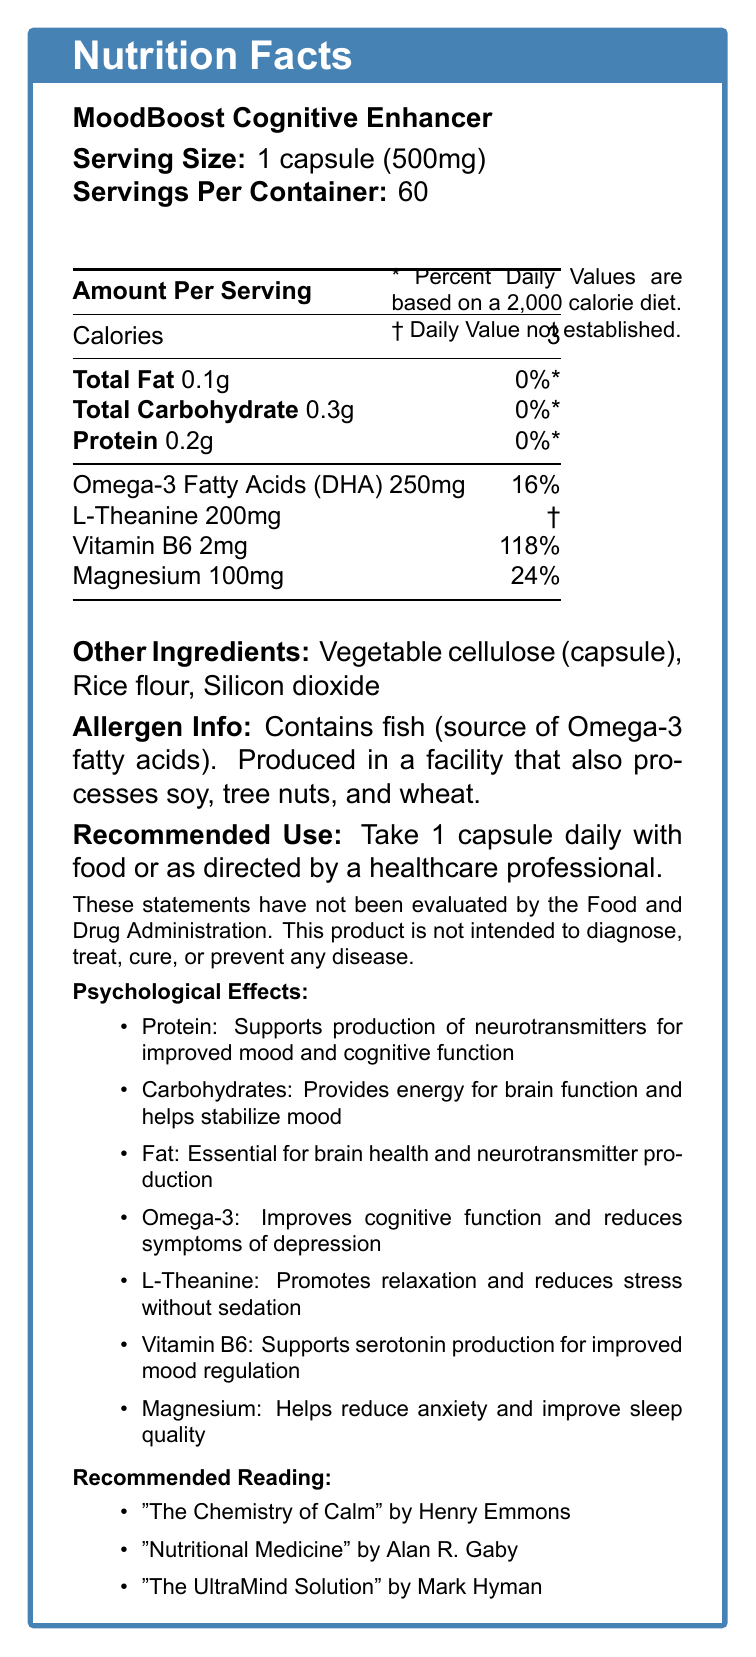what is the serving size for MoodBoost Cognitive Enhancer? The serving size is clearly mentioned in the document as "1 capsule (500mg)".
Answer: 1 capsule (500mg) how much protein does one capsule contain? The document specifies that one capsule contains 0.2g of protein.
Answer: 0.2g what percentage of the daily value for Vitamin B6 does one capsule provide? According to the document, one capsule provides 118% of the daily value for Vitamin B6.
Answer: 118% how does L-Theanine psychologically affect mood and cognition? The psychological effects of L-Theanine are noted in the document as promoting relaxation and reducing stress without sedation.
Answer: Promotes relaxation and reduces stress without sedation what is the main dietary source of Omega-3 fatty acids in this supplement? The document states that the supplement contains fish as the source of Omega-3 fatty acids.
Answer: Fish which macronutrient in this supplement is essential for brain health and neurotransmitter production? A. Carbohydrates B. Protein C. Fat D. L-Theanine The document mentions that fat is essential for brain health and neurotransmitter production.
Answer: C. Fat what is the serving size of Omega-3 Fatty Acids (DHA) per capsule? A. 2mg B. 100mg C. 200mg D. 250mg The serving size of Omega-3 Fatty Acids (DHA) per capsule is listed as 250mg in the document.
Answer: D. 250mg does this product contain any allergens? The document mentions that the product contains fish and is produced in a facility that processes soy, tree nuts, and wheat.
Answer: Yes summarize the main idea of the document. The document provides comprehensive nutritional information about the supplement, including macronutrients, micronutrients, their psychological effects, ingredients, allergy information, usage recommendations, and references to related books.
Answer: The document provides the Nutrition Facts for "MoodBoost Cognitive Enhancer", detailing serving size, macronutrient and micronutrient content, psychological effects, other ingredients, allergen information, recommended use, and relevant book references on nutrition and mental health. what are the total calories in one serving of MoodBoost Cognitive Enhancer? The document states that one serving of the supplement contains 3 calories.
Answer: 3 calories which nutrient in this supplement aids in energy provision for brain function and mood stabilization? The psychological effects of carbohydrates listed in the document indicate that they provide energy for brain function and help stabilize mood.
Answer: Carbohydrates who is the author of "The Chemistry of Calm"? The document lists Henry Emmons as the author of "The Chemistry of Calm."
Answer: Henry Emmons what percentage of the daily value for Magnesium does one capsule provide? The document mentions that one capsule provides 24% of the daily value for Magnesium.
Answer: 24% what are the main psychological effects of protein according to the document? The document notes that protein supports neurotransmitter production for improved mood and cognitive function.
Answer: Supports production of neurotransmitters for improved mood and cognitive function can we determine the exact percentage of daily value for L-Theanine? The document states that the daily value for L-Theanine is not established.
Answer: No is vitamin B6 more effective in mood regulation than Magnesium according to the document? The document highlights the psychological effects of both nutrients but does not provide a direct comparison of their effectiveness in mood regulation.
Answer: Cannot be determined 